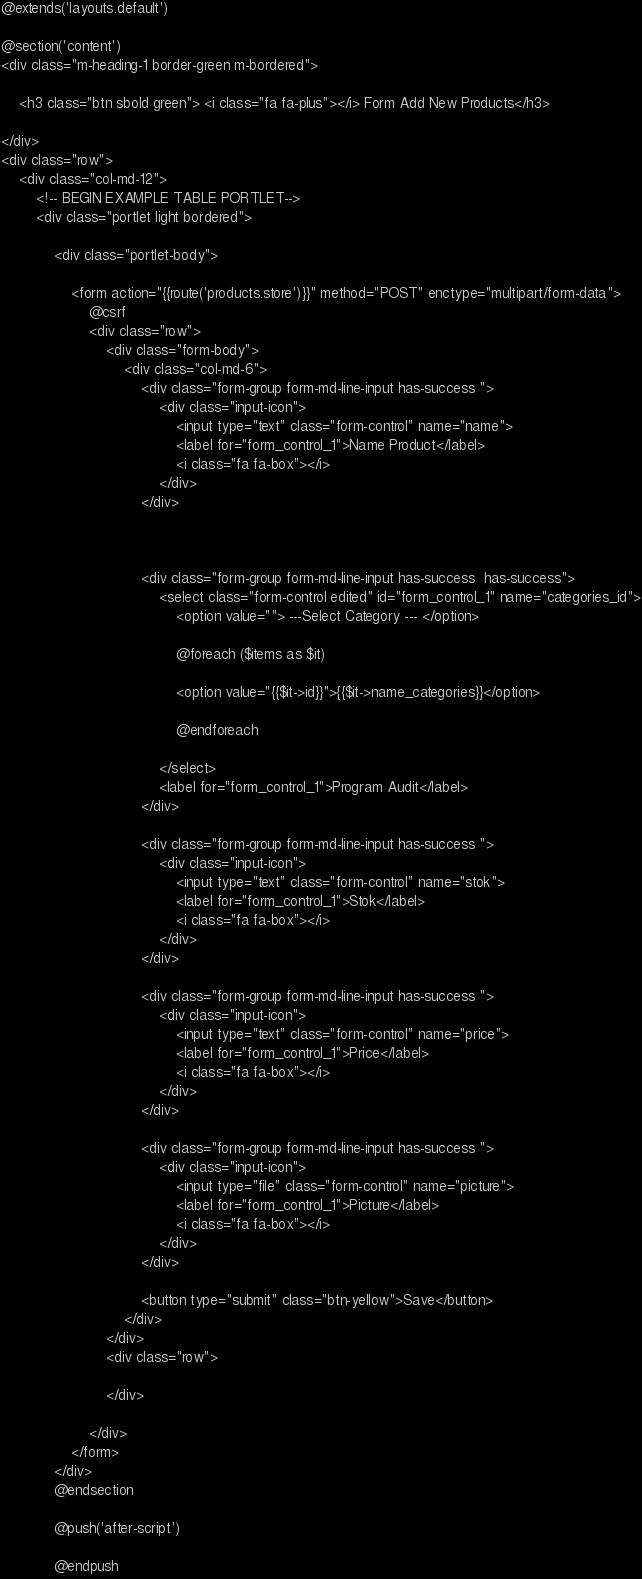<code> <loc_0><loc_0><loc_500><loc_500><_PHP_>@extends('layouts.default')

@section('content')
<div class="m-heading-1 border-green m-bordered">

    <h3 class="btn sbold green"> <i class="fa fa-plus"></i> Form Add New Products</h3>

</div>
<div class="row">
    <div class="col-md-12">
        <!-- BEGIN EXAMPLE TABLE PORTLET-->
        <div class="portlet light bordered">

            <div class="portlet-body">

                <form action="{{route('products.store')}}" method="POST" enctype="multipart/form-data">
                    @csrf
                    <div class="row">
                        <div class="form-body">
                            <div class="col-md-6">
                                <div class="form-group form-md-line-input has-success ">
                                    <div class="input-icon">
                                        <input type="text" class="form-control" name="name">
                                        <label for="form_control_1">Name Product</label>
                                        <i class="fa fa-box"></i>
                                    </div>
                                </div>



                                <div class="form-group form-md-line-input has-success  has-success">
                                    <select class="form-control edited" id="form_control_1" name="categories_id">
                                        <option value=""> ---Select Category --- </option>

                                        @foreach ($items as $it)

                                        <option value="{{$it->id}}">{{$it->name_categories}}</option>

                                        @endforeach

                                    </select>
                                    <label for="form_control_1">Program Audit</label>
                                </div>

                                <div class="form-group form-md-line-input has-success ">
                                    <div class="input-icon">
                                        <input type="text" class="form-control" name="stok">
                                        <label for="form_control_1">Stok</label>
                                        <i class="fa fa-box"></i>
                                    </div>
                                </div>

                                <div class="form-group form-md-line-input has-success ">
                                    <div class="input-icon">
                                        <input type="text" class="form-control" name="price">
                                        <label for="form_control_1">Price</label>
                                        <i class="fa fa-box"></i>
                                    </div>
                                </div>

                                <div class="form-group form-md-line-input has-success ">
                                    <div class="input-icon">
                                        <input type="file" class="form-control" name="picture">
                                        <label for="form_control_1">Picture</label>
                                        <i class="fa fa-box"></i>
                                    </div>
                                </div>

                                <button type="submit" class="btn-yellow">Save</button>
                            </div>
                        </div>
                        <div class="row">

                        </div>

                    </div>
                </form>
            </div>
            @endsection

            @push('after-script')

            @endpush
</code> 